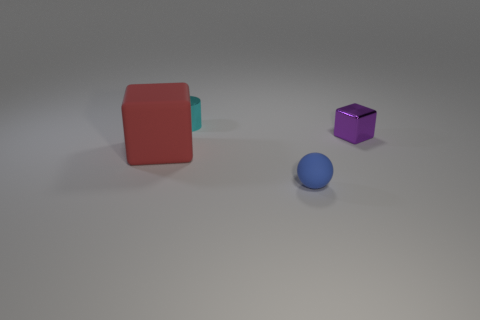There is a large matte object that is the same shape as the purple metallic thing; what is its color?
Your answer should be very brief. Red. Is the size of the matte thing in front of the large red rubber object the same as the object behind the purple metallic thing?
Keep it short and to the point. Yes. Is the size of the cyan metallic object the same as the shiny object on the right side of the tiny cyan thing?
Your response must be concise. Yes. How big is the blue matte sphere?
Provide a succinct answer. Small. The cylinder that is the same material as the purple block is what color?
Give a very brief answer. Cyan. How many blue things are the same material as the big red thing?
Offer a terse response. 1. How many objects are tiny blue matte balls or small objects that are behind the blue matte object?
Your answer should be compact. 3. Is the material of the thing that is to the left of the tiny cyan cylinder the same as the tiny blue ball?
Keep it short and to the point. Yes. What is the color of the matte thing that is the same size as the purple shiny thing?
Keep it short and to the point. Blue. Are there any other matte things of the same shape as the small purple thing?
Keep it short and to the point. Yes. 